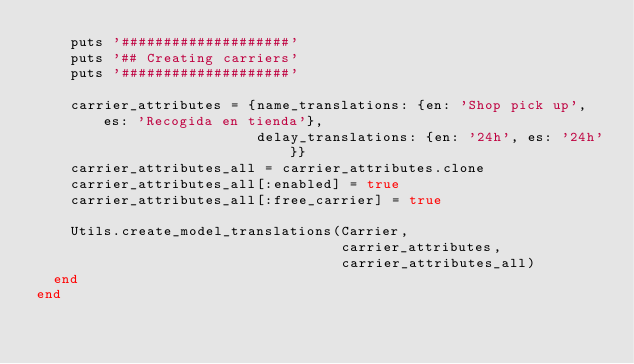<code> <loc_0><loc_0><loc_500><loc_500><_Ruby_>    puts '####################'
    puts '## Creating carriers'
    puts '####################'

    carrier_attributes = {name_translations: {en: 'Shop pick up', es: 'Recogida en tienda'},
                          delay_translations: {en: '24h', es: '24h'}}
    carrier_attributes_all = carrier_attributes.clone
    carrier_attributes_all[:enabled] = true
    carrier_attributes_all[:free_carrier] = true

    Utils.create_model_translations(Carrier,
                                    carrier_attributes,
                                    carrier_attributes_all)
  end
end</code> 